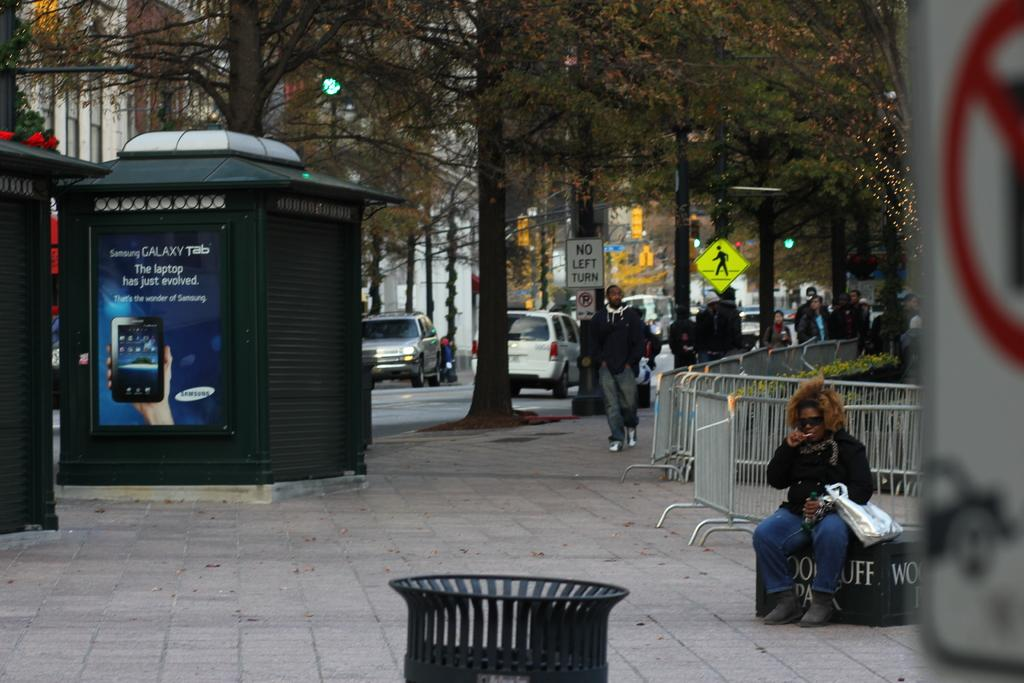<image>
Offer a succinct explanation of the picture presented. A sidewalk has a bus stop with an ad on it that says Galaxy Tab. 